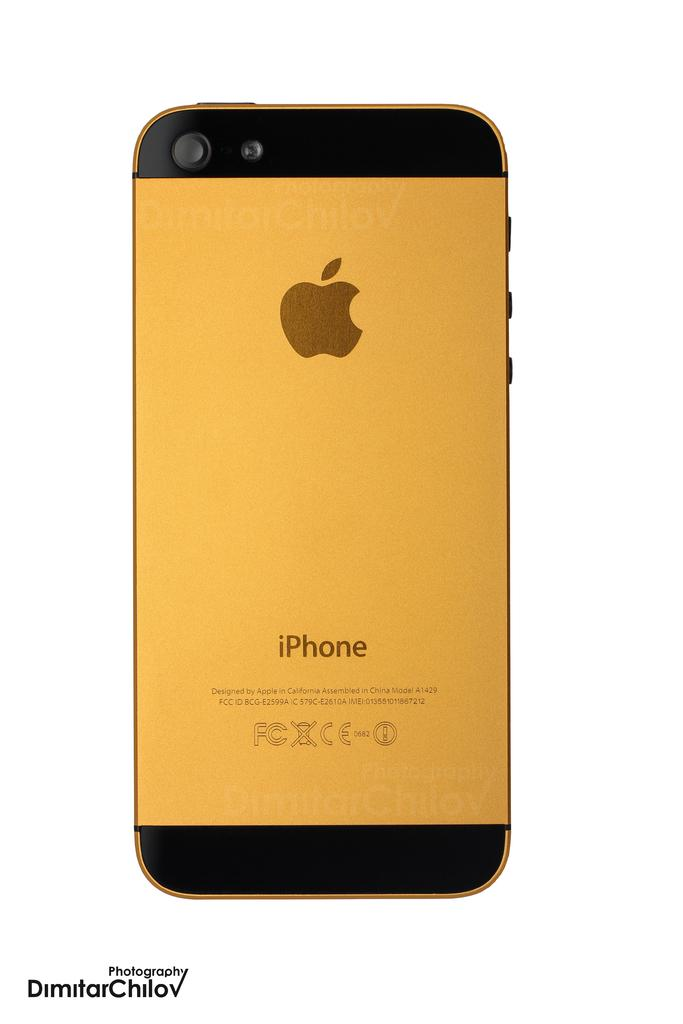<image>
Give a short and clear explanation of the subsequent image. A yellow phone face down on the table with iphone written near the bottom 